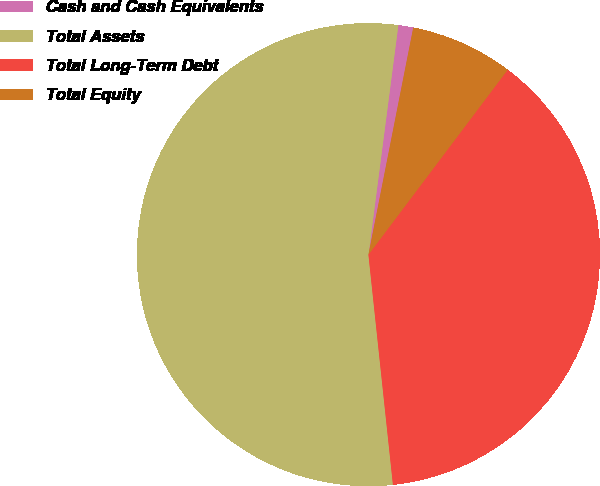Convert chart to OTSL. <chart><loc_0><loc_0><loc_500><loc_500><pie_chart><fcel>Cash and Cash Equivalents<fcel>Total Assets<fcel>Total Long-Term Debt<fcel>Total Equity<nl><fcel>1.04%<fcel>53.75%<fcel>38.04%<fcel>7.17%<nl></chart> 